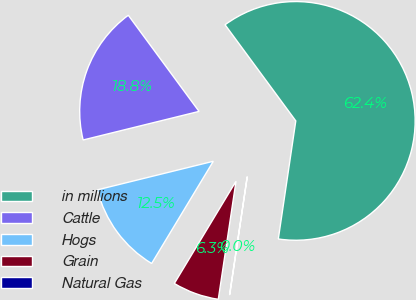<chart> <loc_0><loc_0><loc_500><loc_500><pie_chart><fcel>in millions<fcel>Cattle<fcel>Hogs<fcel>Grain<fcel>Natural Gas<nl><fcel>62.43%<fcel>18.75%<fcel>12.51%<fcel>6.27%<fcel>0.03%<nl></chart> 